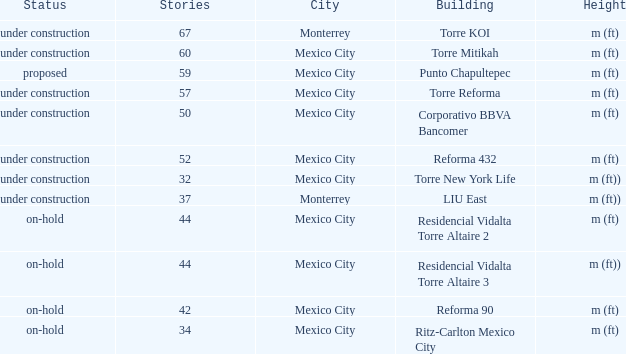How many stories is the torre reforma building? 1.0. 